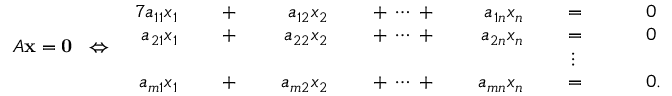Convert formula to latex. <formula><loc_0><loc_0><loc_500><loc_500>A x = 0 \, \Leftrightarrow \, { \begin{array} { r l r l r l r l r l r l r l } { { 7 } a _ { 1 1 } x _ { 1 } } & { \, + \, } & { a _ { 1 2 } x _ { 2 } } & { \, + \, \cdots \, + \, } & { a _ { 1 n } x _ { n } } & { \, = \, } & & { 0 } \\ { a _ { 2 1 } x _ { 1 } } & { \, + \, } & { a _ { 2 2 } x _ { 2 } } & { \, + \, \cdots \, + \, } & { a _ { 2 n } x _ { n } } & { \, = \, } & & { 0 } \\ & & & & & { \vdots \ \, } & \\ { a _ { m 1 } x _ { 1 } } & { \, + \, } & { a _ { m 2 } x _ { 2 } } & { \, + \, \cdots \, + \, } & { a _ { m n } x _ { n } } & { \, = \, } & & { 0 { . } } \end{array} }</formula> 